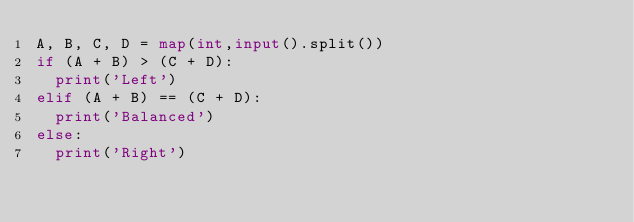Convert code to text. <code><loc_0><loc_0><loc_500><loc_500><_Python_>A, B, C, D = map(int,input().split())
if (A + B) > (C + D):
  print('Left')
elif (A + B) == (C + D):
  print('Balanced')
else:
  print('Right')</code> 